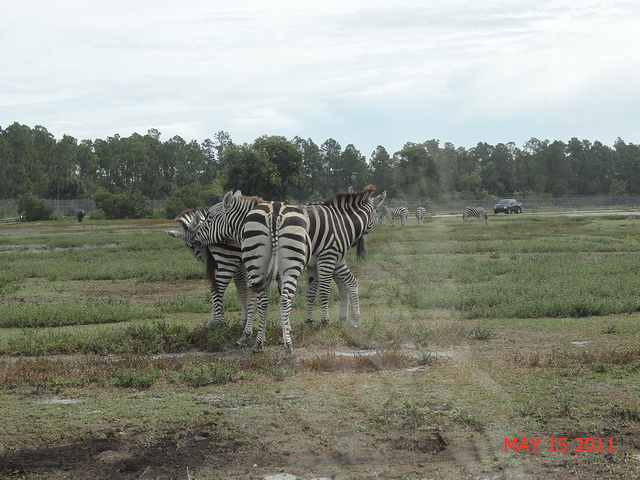Can you tell anything about the weather in the photo? The sky is overcast, and the light is diffused without harsh shadows, indicating that the weather is cloudy. The absence of visible precipitation or wetness on the ground suggests that it's probably not raining at the moment the picture was taken. 